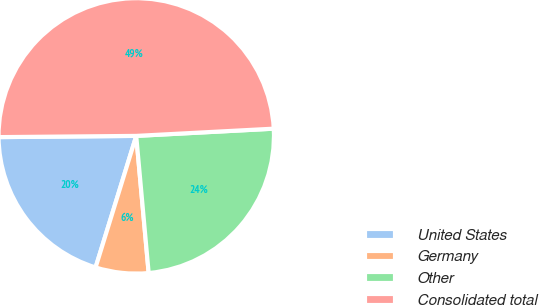Convert chart. <chart><loc_0><loc_0><loc_500><loc_500><pie_chart><fcel>United States<fcel>Germany<fcel>Other<fcel>Consolidated total<nl><fcel>20.09%<fcel>6.21%<fcel>24.4%<fcel>49.31%<nl></chart> 